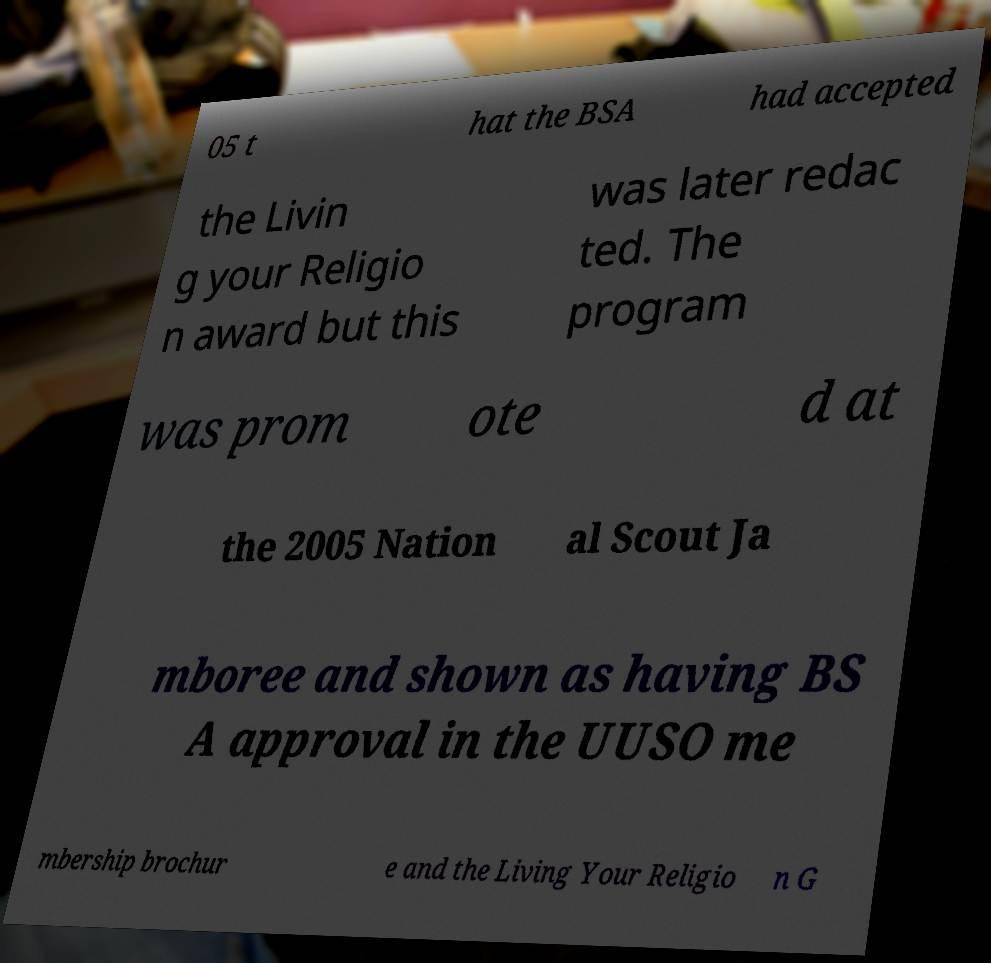Can you read and provide the text displayed in the image?This photo seems to have some interesting text. Can you extract and type it out for me? 05 t hat the BSA had accepted the Livin g your Religio n award but this was later redac ted. The program was prom ote d at the 2005 Nation al Scout Ja mboree and shown as having BS A approval in the UUSO me mbership brochur e and the Living Your Religio n G 